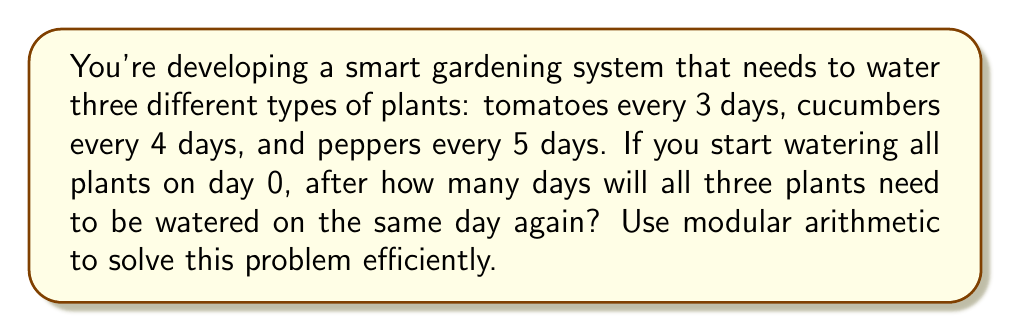Show me your answer to this math problem. Let's approach this step-by-step using modular arithmetic and the concept of least common multiple (LCM):

1) We need to find a number $n$ such that:
   $n \equiv 0 \pmod{3}$ (for tomatoes)
   $n \equiv 0 \pmod{4}$ (for cucumbers)
   $n \equiv 0 \pmod{5}$ (for peppers)

2) This is equivalent to finding the least common multiple (LCM) of 3, 4, and 5.

3) To find the LCM, let's first find the prime factorization of each number:
   $3 = 3$
   $4 = 2^2$
   $5 = 5$

4) The LCM will include the highest power of each prime factor:
   $LCM(3,4,5) = 2^2 \times 3 \times 5$

5) Calculate the result:
   $LCM(3,4,5) = 4 \times 3 \times 5 = 60$

6) Therefore, all plants will need to be watered on the same day every 60 days.

7) We can verify this using modular arithmetic:
   $60 \equiv 0 \pmod{3}$
   $60 \equiv 0 \pmod{4}$
   $60 \equiv 0 \pmod{5}$

This solution allows for efficient scheduling in the smart gardening system, as it determines the cycle after which the watering pattern repeats for all plants.
Answer: 60 days 